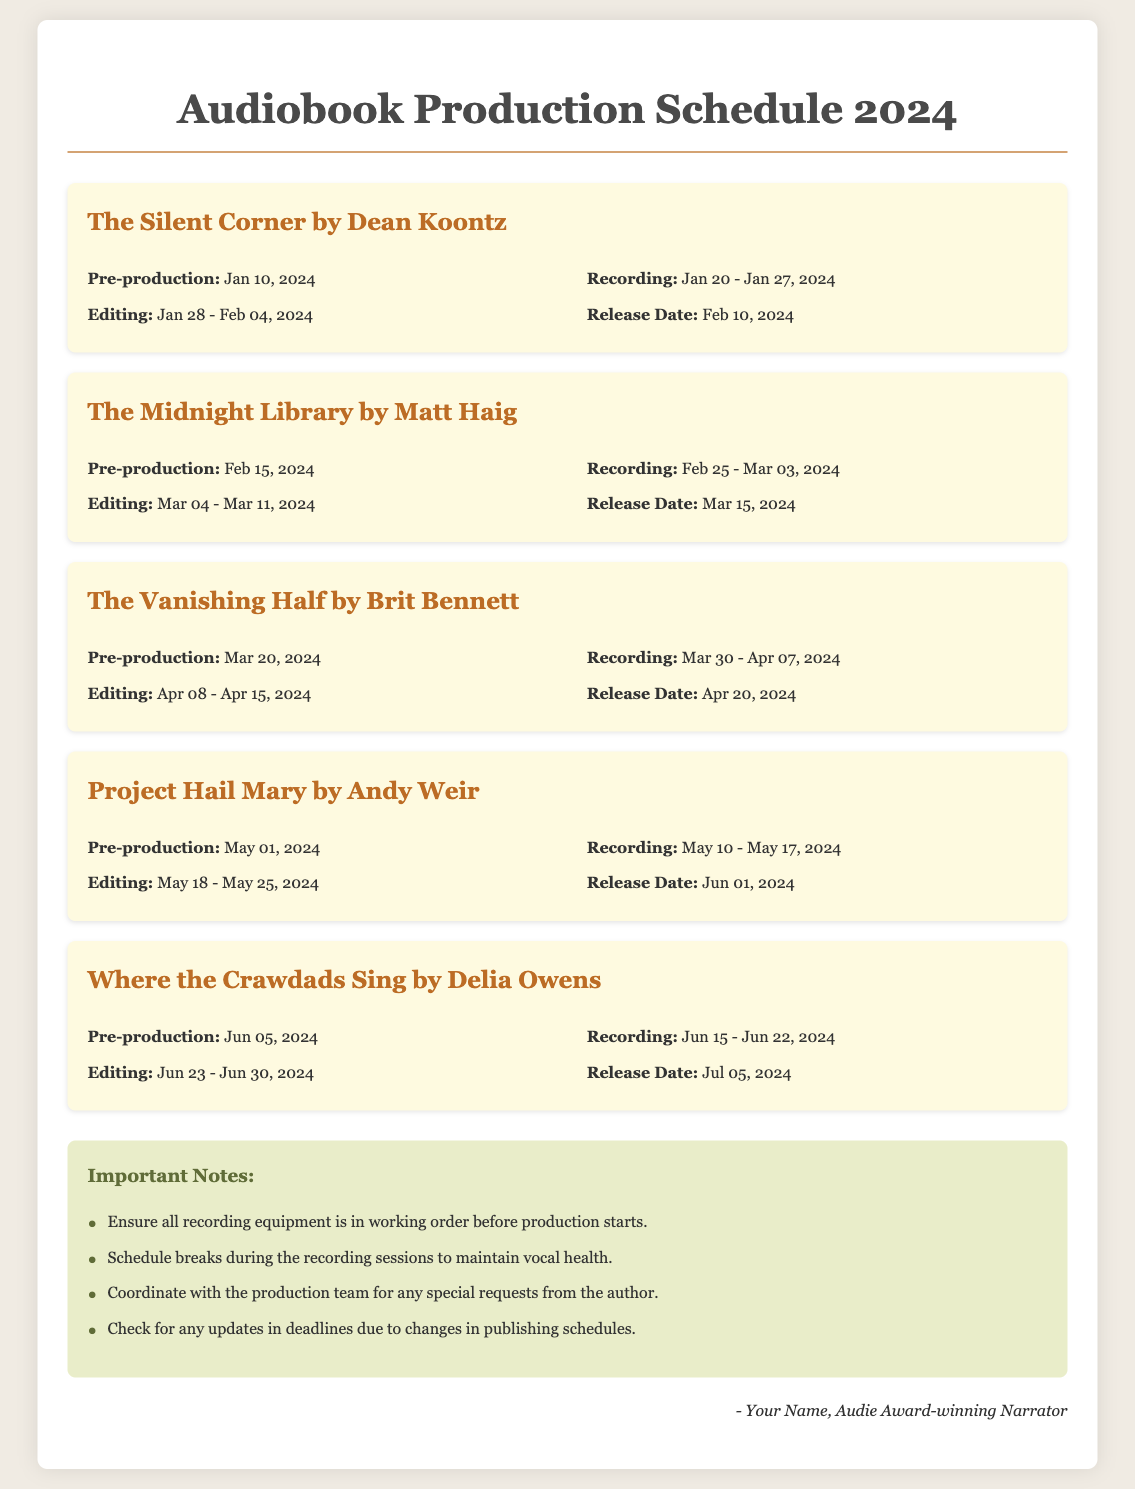What is the release date for The Silent Corner? The release date is specified in the project details and is set for February 10, 2024.
Answer: February 10, 2024 When does pre-production for The Midnight Library start? The document states the pre-production date, which is February 15, 2024.
Answer: February 15, 2024 How many days does the recording of Where the Crawdads Sing take place? The recording dates for Where the Crawdads Sing are from June 15 to June 22, giving it a duration of 8 days.
Answer: 8 days What project has the latest pre-production start date? This is determined by comparing pre-production start dates across all projects, with Project Hail Mary starting on May 1, 2024.
Answer: Project Hail Mary What is one important note for the production team? The document lists several notes, one of which is to ensure all recording equipment is in working order before production starts.
Answer: Ensure all recording equipment is in working order What is the editing period for The Vanishing Half? The editing period is outlined in the project details, running from April 8 to April 15, 2024.
Answer: April 8 - April 15, 2024 Which project is scheduled to be released in July 2024? By reviewing the release dates provided, Where the Crawdads Sing is the only project scheduled for that month.
Answer: Where the Crawdads Sing When is the recording period for Project Hail Mary? The recording period is detailed as occurring from May 10 to May 17, 2024.
Answer: May 10 - May 17, 2024 